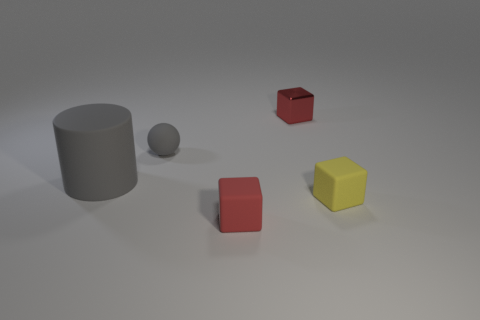Are there any other things that have the same size as the gray matte cylinder?
Provide a succinct answer. No. What is the shape of the small red object that is in front of the tiny matte cube behind the rubber cube in front of the small yellow rubber cube?
Ensure brevity in your answer.  Cube. Does the red metallic thing have the same shape as the small red matte thing?
Ensure brevity in your answer.  Yes. How many other objects are the same shape as the red shiny thing?
Your answer should be very brief. 2. What color is the rubber ball that is the same size as the red rubber cube?
Provide a succinct answer. Gray. Is the number of rubber cylinders right of the gray ball the same as the number of gray spheres?
Your answer should be compact. No. There is a tiny matte object that is on the left side of the tiny metallic object and to the right of the small sphere; what shape is it?
Offer a terse response. Cube. Is the red matte thing the same size as the rubber ball?
Your answer should be very brief. Yes. Are there any small cyan cylinders made of the same material as the sphere?
Your response must be concise. No. The thing that is the same color as the matte sphere is what size?
Offer a terse response. Large. 